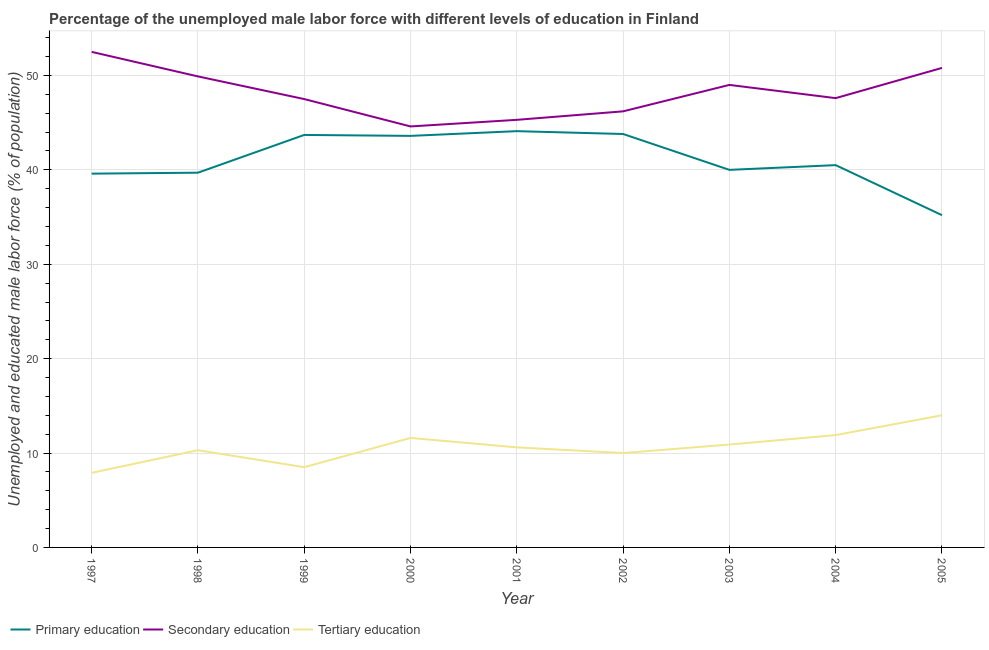How many different coloured lines are there?
Your response must be concise. 3. What is the percentage of male labor force who received primary education in 2005?
Offer a very short reply. 35.2. Across all years, what is the maximum percentage of male labor force who received tertiary education?
Provide a short and direct response. 14. Across all years, what is the minimum percentage of male labor force who received primary education?
Provide a short and direct response. 35.2. In which year was the percentage of male labor force who received primary education maximum?
Provide a succinct answer. 2001. What is the total percentage of male labor force who received secondary education in the graph?
Provide a succinct answer. 433.4. What is the difference between the percentage of male labor force who received secondary education in 2002 and that in 2003?
Ensure brevity in your answer.  -2.8. What is the difference between the percentage of male labor force who received primary education in 2001 and the percentage of male labor force who received tertiary education in 2002?
Provide a short and direct response. 34.1. What is the average percentage of male labor force who received secondary education per year?
Provide a short and direct response. 48.16. In the year 2005, what is the difference between the percentage of male labor force who received primary education and percentage of male labor force who received secondary education?
Offer a terse response. -15.6. What is the ratio of the percentage of male labor force who received secondary education in 1997 to that in 2004?
Make the answer very short. 1.1. What is the difference between the highest and the second highest percentage of male labor force who received secondary education?
Give a very brief answer. 1.7. What is the difference between the highest and the lowest percentage of male labor force who received primary education?
Keep it short and to the point. 8.9. In how many years, is the percentage of male labor force who received primary education greater than the average percentage of male labor force who received primary education taken over all years?
Provide a short and direct response. 4. Is it the case that in every year, the sum of the percentage of male labor force who received primary education and percentage of male labor force who received secondary education is greater than the percentage of male labor force who received tertiary education?
Your answer should be compact. Yes. Is the percentage of male labor force who received tertiary education strictly less than the percentage of male labor force who received secondary education over the years?
Give a very brief answer. Yes. How many lines are there?
Keep it short and to the point. 3. Does the graph contain any zero values?
Your answer should be compact. No. How many legend labels are there?
Your answer should be very brief. 3. What is the title of the graph?
Provide a succinct answer. Percentage of the unemployed male labor force with different levels of education in Finland. What is the label or title of the X-axis?
Your response must be concise. Year. What is the label or title of the Y-axis?
Keep it short and to the point. Unemployed and educated male labor force (% of population). What is the Unemployed and educated male labor force (% of population) in Primary education in 1997?
Your answer should be very brief. 39.6. What is the Unemployed and educated male labor force (% of population) in Secondary education in 1997?
Make the answer very short. 52.5. What is the Unemployed and educated male labor force (% of population) in Tertiary education in 1997?
Make the answer very short. 7.9. What is the Unemployed and educated male labor force (% of population) in Primary education in 1998?
Your answer should be compact. 39.7. What is the Unemployed and educated male labor force (% of population) in Secondary education in 1998?
Provide a short and direct response. 49.9. What is the Unemployed and educated male labor force (% of population) of Tertiary education in 1998?
Your answer should be very brief. 10.3. What is the Unemployed and educated male labor force (% of population) of Primary education in 1999?
Keep it short and to the point. 43.7. What is the Unemployed and educated male labor force (% of population) in Secondary education in 1999?
Offer a terse response. 47.5. What is the Unemployed and educated male labor force (% of population) in Primary education in 2000?
Provide a succinct answer. 43.6. What is the Unemployed and educated male labor force (% of population) in Secondary education in 2000?
Make the answer very short. 44.6. What is the Unemployed and educated male labor force (% of population) of Tertiary education in 2000?
Provide a succinct answer. 11.6. What is the Unemployed and educated male labor force (% of population) of Primary education in 2001?
Make the answer very short. 44.1. What is the Unemployed and educated male labor force (% of population) of Secondary education in 2001?
Provide a succinct answer. 45.3. What is the Unemployed and educated male labor force (% of population) of Tertiary education in 2001?
Keep it short and to the point. 10.6. What is the Unemployed and educated male labor force (% of population) in Primary education in 2002?
Keep it short and to the point. 43.8. What is the Unemployed and educated male labor force (% of population) in Secondary education in 2002?
Make the answer very short. 46.2. What is the Unemployed and educated male labor force (% of population) in Tertiary education in 2002?
Provide a succinct answer. 10. What is the Unemployed and educated male labor force (% of population) of Tertiary education in 2003?
Make the answer very short. 10.9. What is the Unemployed and educated male labor force (% of population) of Primary education in 2004?
Keep it short and to the point. 40.5. What is the Unemployed and educated male labor force (% of population) of Secondary education in 2004?
Make the answer very short. 47.6. What is the Unemployed and educated male labor force (% of population) in Tertiary education in 2004?
Your response must be concise. 11.9. What is the Unemployed and educated male labor force (% of population) of Primary education in 2005?
Ensure brevity in your answer.  35.2. What is the Unemployed and educated male labor force (% of population) of Secondary education in 2005?
Keep it short and to the point. 50.8. Across all years, what is the maximum Unemployed and educated male labor force (% of population) in Primary education?
Your answer should be compact. 44.1. Across all years, what is the maximum Unemployed and educated male labor force (% of population) of Secondary education?
Make the answer very short. 52.5. Across all years, what is the maximum Unemployed and educated male labor force (% of population) of Tertiary education?
Provide a short and direct response. 14. Across all years, what is the minimum Unemployed and educated male labor force (% of population) of Primary education?
Give a very brief answer. 35.2. Across all years, what is the minimum Unemployed and educated male labor force (% of population) of Secondary education?
Offer a terse response. 44.6. Across all years, what is the minimum Unemployed and educated male labor force (% of population) of Tertiary education?
Provide a short and direct response. 7.9. What is the total Unemployed and educated male labor force (% of population) of Primary education in the graph?
Provide a short and direct response. 370.2. What is the total Unemployed and educated male labor force (% of population) in Secondary education in the graph?
Provide a succinct answer. 433.4. What is the total Unemployed and educated male labor force (% of population) in Tertiary education in the graph?
Provide a short and direct response. 95.7. What is the difference between the Unemployed and educated male labor force (% of population) in Tertiary education in 1997 and that in 1998?
Provide a short and direct response. -2.4. What is the difference between the Unemployed and educated male labor force (% of population) in Secondary education in 1997 and that in 1999?
Your response must be concise. 5. What is the difference between the Unemployed and educated male labor force (% of population) in Secondary education in 1997 and that in 2000?
Your response must be concise. 7.9. What is the difference between the Unemployed and educated male labor force (% of population) of Tertiary education in 1997 and that in 2000?
Make the answer very short. -3.7. What is the difference between the Unemployed and educated male labor force (% of population) in Secondary education in 1997 and that in 2001?
Offer a terse response. 7.2. What is the difference between the Unemployed and educated male labor force (% of population) in Primary education in 1997 and that in 2002?
Your response must be concise. -4.2. What is the difference between the Unemployed and educated male labor force (% of population) in Primary education in 1997 and that in 2003?
Make the answer very short. -0.4. What is the difference between the Unemployed and educated male labor force (% of population) in Tertiary education in 1997 and that in 2003?
Keep it short and to the point. -3. What is the difference between the Unemployed and educated male labor force (% of population) of Secondary education in 1997 and that in 2004?
Make the answer very short. 4.9. What is the difference between the Unemployed and educated male labor force (% of population) of Tertiary education in 1997 and that in 2004?
Make the answer very short. -4. What is the difference between the Unemployed and educated male labor force (% of population) in Secondary education in 1997 and that in 2005?
Your response must be concise. 1.7. What is the difference between the Unemployed and educated male labor force (% of population) of Secondary education in 1998 and that in 2000?
Keep it short and to the point. 5.3. What is the difference between the Unemployed and educated male labor force (% of population) in Secondary education in 1998 and that in 2001?
Make the answer very short. 4.6. What is the difference between the Unemployed and educated male labor force (% of population) of Tertiary education in 1998 and that in 2001?
Provide a succinct answer. -0.3. What is the difference between the Unemployed and educated male labor force (% of population) in Secondary education in 1998 and that in 2002?
Keep it short and to the point. 3.7. What is the difference between the Unemployed and educated male labor force (% of population) in Tertiary education in 1998 and that in 2002?
Your answer should be compact. 0.3. What is the difference between the Unemployed and educated male labor force (% of population) in Secondary education in 1998 and that in 2003?
Your response must be concise. 0.9. What is the difference between the Unemployed and educated male labor force (% of population) of Tertiary education in 1998 and that in 2003?
Give a very brief answer. -0.6. What is the difference between the Unemployed and educated male labor force (% of population) of Secondary education in 1998 and that in 2004?
Give a very brief answer. 2.3. What is the difference between the Unemployed and educated male labor force (% of population) in Tertiary education in 1998 and that in 2004?
Keep it short and to the point. -1.6. What is the difference between the Unemployed and educated male labor force (% of population) in Secondary education in 1998 and that in 2005?
Provide a short and direct response. -0.9. What is the difference between the Unemployed and educated male labor force (% of population) in Tertiary education in 1998 and that in 2005?
Provide a short and direct response. -3.7. What is the difference between the Unemployed and educated male labor force (% of population) in Primary education in 1999 and that in 2000?
Your answer should be very brief. 0.1. What is the difference between the Unemployed and educated male labor force (% of population) of Secondary education in 1999 and that in 2000?
Ensure brevity in your answer.  2.9. What is the difference between the Unemployed and educated male labor force (% of population) in Primary education in 1999 and that in 2002?
Make the answer very short. -0.1. What is the difference between the Unemployed and educated male labor force (% of population) of Tertiary education in 1999 and that in 2002?
Provide a succinct answer. -1.5. What is the difference between the Unemployed and educated male labor force (% of population) of Primary education in 1999 and that in 2003?
Offer a terse response. 3.7. What is the difference between the Unemployed and educated male labor force (% of population) of Secondary education in 1999 and that in 2003?
Make the answer very short. -1.5. What is the difference between the Unemployed and educated male labor force (% of population) in Tertiary education in 1999 and that in 2003?
Provide a short and direct response. -2.4. What is the difference between the Unemployed and educated male labor force (% of population) of Tertiary education in 1999 and that in 2004?
Offer a terse response. -3.4. What is the difference between the Unemployed and educated male labor force (% of population) in Primary education in 1999 and that in 2005?
Your answer should be compact. 8.5. What is the difference between the Unemployed and educated male labor force (% of population) in Secondary education in 1999 and that in 2005?
Make the answer very short. -3.3. What is the difference between the Unemployed and educated male labor force (% of population) of Tertiary education in 1999 and that in 2005?
Give a very brief answer. -5.5. What is the difference between the Unemployed and educated male labor force (% of population) in Primary education in 2000 and that in 2001?
Your answer should be compact. -0.5. What is the difference between the Unemployed and educated male labor force (% of population) in Primary education in 2000 and that in 2002?
Provide a short and direct response. -0.2. What is the difference between the Unemployed and educated male labor force (% of population) in Secondary education in 2000 and that in 2002?
Make the answer very short. -1.6. What is the difference between the Unemployed and educated male labor force (% of population) of Primary education in 2000 and that in 2003?
Provide a succinct answer. 3.6. What is the difference between the Unemployed and educated male labor force (% of population) in Tertiary education in 2000 and that in 2003?
Provide a short and direct response. 0.7. What is the difference between the Unemployed and educated male labor force (% of population) in Tertiary education in 2000 and that in 2004?
Provide a short and direct response. -0.3. What is the difference between the Unemployed and educated male labor force (% of population) in Secondary education in 2001 and that in 2002?
Provide a succinct answer. -0.9. What is the difference between the Unemployed and educated male labor force (% of population) of Primary education in 2001 and that in 2003?
Your response must be concise. 4.1. What is the difference between the Unemployed and educated male labor force (% of population) of Secondary education in 2001 and that in 2003?
Provide a succinct answer. -3.7. What is the difference between the Unemployed and educated male labor force (% of population) of Primary education in 2001 and that in 2004?
Give a very brief answer. 3.6. What is the difference between the Unemployed and educated male labor force (% of population) of Secondary education in 2001 and that in 2004?
Offer a very short reply. -2.3. What is the difference between the Unemployed and educated male labor force (% of population) of Tertiary education in 2001 and that in 2004?
Ensure brevity in your answer.  -1.3. What is the difference between the Unemployed and educated male labor force (% of population) in Primary education in 2001 and that in 2005?
Offer a very short reply. 8.9. What is the difference between the Unemployed and educated male labor force (% of population) of Secondary education in 2002 and that in 2003?
Provide a short and direct response. -2.8. What is the difference between the Unemployed and educated male labor force (% of population) of Tertiary education in 2002 and that in 2004?
Offer a very short reply. -1.9. What is the difference between the Unemployed and educated male labor force (% of population) of Tertiary education in 2002 and that in 2005?
Your answer should be very brief. -4. What is the difference between the Unemployed and educated male labor force (% of population) in Primary education in 2003 and that in 2004?
Provide a short and direct response. -0.5. What is the difference between the Unemployed and educated male labor force (% of population) of Secondary education in 2003 and that in 2004?
Provide a succinct answer. 1.4. What is the difference between the Unemployed and educated male labor force (% of population) of Primary education in 2003 and that in 2005?
Give a very brief answer. 4.8. What is the difference between the Unemployed and educated male labor force (% of population) of Tertiary education in 2003 and that in 2005?
Your answer should be very brief. -3.1. What is the difference between the Unemployed and educated male labor force (% of population) of Tertiary education in 2004 and that in 2005?
Your answer should be compact. -2.1. What is the difference between the Unemployed and educated male labor force (% of population) of Primary education in 1997 and the Unemployed and educated male labor force (% of population) of Tertiary education in 1998?
Keep it short and to the point. 29.3. What is the difference between the Unemployed and educated male labor force (% of population) of Secondary education in 1997 and the Unemployed and educated male labor force (% of population) of Tertiary education in 1998?
Keep it short and to the point. 42.2. What is the difference between the Unemployed and educated male labor force (% of population) of Primary education in 1997 and the Unemployed and educated male labor force (% of population) of Tertiary education in 1999?
Provide a succinct answer. 31.1. What is the difference between the Unemployed and educated male labor force (% of population) in Secondary education in 1997 and the Unemployed and educated male labor force (% of population) in Tertiary education in 2000?
Ensure brevity in your answer.  40.9. What is the difference between the Unemployed and educated male labor force (% of population) in Primary education in 1997 and the Unemployed and educated male labor force (% of population) in Secondary education in 2001?
Provide a short and direct response. -5.7. What is the difference between the Unemployed and educated male labor force (% of population) in Primary education in 1997 and the Unemployed and educated male labor force (% of population) in Tertiary education in 2001?
Give a very brief answer. 29. What is the difference between the Unemployed and educated male labor force (% of population) in Secondary education in 1997 and the Unemployed and educated male labor force (% of population) in Tertiary education in 2001?
Your answer should be compact. 41.9. What is the difference between the Unemployed and educated male labor force (% of population) of Primary education in 1997 and the Unemployed and educated male labor force (% of population) of Tertiary education in 2002?
Provide a short and direct response. 29.6. What is the difference between the Unemployed and educated male labor force (% of population) of Secondary education in 1997 and the Unemployed and educated male labor force (% of population) of Tertiary education in 2002?
Your response must be concise. 42.5. What is the difference between the Unemployed and educated male labor force (% of population) of Primary education in 1997 and the Unemployed and educated male labor force (% of population) of Tertiary education in 2003?
Give a very brief answer. 28.7. What is the difference between the Unemployed and educated male labor force (% of population) of Secondary education in 1997 and the Unemployed and educated male labor force (% of population) of Tertiary education in 2003?
Provide a succinct answer. 41.6. What is the difference between the Unemployed and educated male labor force (% of population) of Primary education in 1997 and the Unemployed and educated male labor force (% of population) of Secondary education in 2004?
Offer a terse response. -8. What is the difference between the Unemployed and educated male labor force (% of population) in Primary education in 1997 and the Unemployed and educated male labor force (% of population) in Tertiary education in 2004?
Your answer should be very brief. 27.7. What is the difference between the Unemployed and educated male labor force (% of population) of Secondary education in 1997 and the Unemployed and educated male labor force (% of population) of Tertiary education in 2004?
Ensure brevity in your answer.  40.6. What is the difference between the Unemployed and educated male labor force (% of population) of Primary education in 1997 and the Unemployed and educated male labor force (% of population) of Tertiary education in 2005?
Keep it short and to the point. 25.6. What is the difference between the Unemployed and educated male labor force (% of population) of Secondary education in 1997 and the Unemployed and educated male labor force (% of population) of Tertiary education in 2005?
Provide a short and direct response. 38.5. What is the difference between the Unemployed and educated male labor force (% of population) in Primary education in 1998 and the Unemployed and educated male labor force (% of population) in Secondary education in 1999?
Provide a short and direct response. -7.8. What is the difference between the Unemployed and educated male labor force (% of population) in Primary education in 1998 and the Unemployed and educated male labor force (% of population) in Tertiary education in 1999?
Keep it short and to the point. 31.2. What is the difference between the Unemployed and educated male labor force (% of population) of Secondary education in 1998 and the Unemployed and educated male labor force (% of population) of Tertiary education in 1999?
Keep it short and to the point. 41.4. What is the difference between the Unemployed and educated male labor force (% of population) in Primary education in 1998 and the Unemployed and educated male labor force (% of population) in Secondary education in 2000?
Your response must be concise. -4.9. What is the difference between the Unemployed and educated male labor force (% of population) of Primary education in 1998 and the Unemployed and educated male labor force (% of population) of Tertiary education in 2000?
Your response must be concise. 28.1. What is the difference between the Unemployed and educated male labor force (% of population) of Secondary education in 1998 and the Unemployed and educated male labor force (% of population) of Tertiary education in 2000?
Offer a terse response. 38.3. What is the difference between the Unemployed and educated male labor force (% of population) of Primary education in 1998 and the Unemployed and educated male labor force (% of population) of Secondary education in 2001?
Your answer should be very brief. -5.6. What is the difference between the Unemployed and educated male labor force (% of population) of Primary education in 1998 and the Unemployed and educated male labor force (% of population) of Tertiary education in 2001?
Your answer should be very brief. 29.1. What is the difference between the Unemployed and educated male labor force (% of population) of Secondary education in 1998 and the Unemployed and educated male labor force (% of population) of Tertiary education in 2001?
Your answer should be compact. 39.3. What is the difference between the Unemployed and educated male labor force (% of population) in Primary education in 1998 and the Unemployed and educated male labor force (% of population) in Tertiary education in 2002?
Your answer should be very brief. 29.7. What is the difference between the Unemployed and educated male labor force (% of population) of Secondary education in 1998 and the Unemployed and educated male labor force (% of population) of Tertiary education in 2002?
Provide a short and direct response. 39.9. What is the difference between the Unemployed and educated male labor force (% of population) of Primary education in 1998 and the Unemployed and educated male labor force (% of population) of Secondary education in 2003?
Provide a succinct answer. -9.3. What is the difference between the Unemployed and educated male labor force (% of population) in Primary education in 1998 and the Unemployed and educated male labor force (% of population) in Tertiary education in 2003?
Your response must be concise. 28.8. What is the difference between the Unemployed and educated male labor force (% of population) in Primary education in 1998 and the Unemployed and educated male labor force (% of population) in Tertiary education in 2004?
Your response must be concise. 27.8. What is the difference between the Unemployed and educated male labor force (% of population) of Secondary education in 1998 and the Unemployed and educated male labor force (% of population) of Tertiary education in 2004?
Keep it short and to the point. 38. What is the difference between the Unemployed and educated male labor force (% of population) in Primary education in 1998 and the Unemployed and educated male labor force (% of population) in Secondary education in 2005?
Provide a short and direct response. -11.1. What is the difference between the Unemployed and educated male labor force (% of population) of Primary education in 1998 and the Unemployed and educated male labor force (% of population) of Tertiary education in 2005?
Your answer should be very brief. 25.7. What is the difference between the Unemployed and educated male labor force (% of population) in Secondary education in 1998 and the Unemployed and educated male labor force (% of population) in Tertiary education in 2005?
Ensure brevity in your answer.  35.9. What is the difference between the Unemployed and educated male labor force (% of population) of Primary education in 1999 and the Unemployed and educated male labor force (% of population) of Secondary education in 2000?
Offer a terse response. -0.9. What is the difference between the Unemployed and educated male labor force (% of population) in Primary education in 1999 and the Unemployed and educated male labor force (% of population) in Tertiary education in 2000?
Your response must be concise. 32.1. What is the difference between the Unemployed and educated male labor force (% of population) in Secondary education in 1999 and the Unemployed and educated male labor force (% of population) in Tertiary education in 2000?
Provide a short and direct response. 35.9. What is the difference between the Unemployed and educated male labor force (% of population) of Primary education in 1999 and the Unemployed and educated male labor force (% of population) of Tertiary education in 2001?
Offer a very short reply. 33.1. What is the difference between the Unemployed and educated male labor force (% of population) in Secondary education in 1999 and the Unemployed and educated male labor force (% of population) in Tertiary education in 2001?
Your answer should be very brief. 36.9. What is the difference between the Unemployed and educated male labor force (% of population) in Primary education in 1999 and the Unemployed and educated male labor force (% of population) in Tertiary education in 2002?
Your response must be concise. 33.7. What is the difference between the Unemployed and educated male labor force (% of population) in Secondary education in 1999 and the Unemployed and educated male labor force (% of population) in Tertiary education in 2002?
Provide a short and direct response. 37.5. What is the difference between the Unemployed and educated male labor force (% of population) in Primary education in 1999 and the Unemployed and educated male labor force (% of population) in Secondary education in 2003?
Ensure brevity in your answer.  -5.3. What is the difference between the Unemployed and educated male labor force (% of population) of Primary education in 1999 and the Unemployed and educated male labor force (% of population) of Tertiary education in 2003?
Offer a terse response. 32.8. What is the difference between the Unemployed and educated male labor force (% of population) in Secondary education in 1999 and the Unemployed and educated male labor force (% of population) in Tertiary education in 2003?
Make the answer very short. 36.6. What is the difference between the Unemployed and educated male labor force (% of population) in Primary education in 1999 and the Unemployed and educated male labor force (% of population) in Secondary education in 2004?
Your answer should be compact. -3.9. What is the difference between the Unemployed and educated male labor force (% of population) of Primary education in 1999 and the Unemployed and educated male labor force (% of population) of Tertiary education in 2004?
Offer a very short reply. 31.8. What is the difference between the Unemployed and educated male labor force (% of population) in Secondary education in 1999 and the Unemployed and educated male labor force (% of population) in Tertiary education in 2004?
Make the answer very short. 35.6. What is the difference between the Unemployed and educated male labor force (% of population) of Primary education in 1999 and the Unemployed and educated male labor force (% of population) of Secondary education in 2005?
Offer a terse response. -7.1. What is the difference between the Unemployed and educated male labor force (% of population) of Primary education in 1999 and the Unemployed and educated male labor force (% of population) of Tertiary education in 2005?
Make the answer very short. 29.7. What is the difference between the Unemployed and educated male labor force (% of population) in Secondary education in 1999 and the Unemployed and educated male labor force (% of population) in Tertiary education in 2005?
Give a very brief answer. 33.5. What is the difference between the Unemployed and educated male labor force (% of population) of Secondary education in 2000 and the Unemployed and educated male labor force (% of population) of Tertiary education in 2001?
Provide a short and direct response. 34. What is the difference between the Unemployed and educated male labor force (% of population) of Primary education in 2000 and the Unemployed and educated male labor force (% of population) of Tertiary education in 2002?
Give a very brief answer. 33.6. What is the difference between the Unemployed and educated male labor force (% of population) in Secondary education in 2000 and the Unemployed and educated male labor force (% of population) in Tertiary education in 2002?
Ensure brevity in your answer.  34.6. What is the difference between the Unemployed and educated male labor force (% of population) in Primary education in 2000 and the Unemployed and educated male labor force (% of population) in Tertiary education in 2003?
Make the answer very short. 32.7. What is the difference between the Unemployed and educated male labor force (% of population) in Secondary education in 2000 and the Unemployed and educated male labor force (% of population) in Tertiary education in 2003?
Make the answer very short. 33.7. What is the difference between the Unemployed and educated male labor force (% of population) in Primary education in 2000 and the Unemployed and educated male labor force (% of population) in Secondary education in 2004?
Your answer should be compact. -4. What is the difference between the Unemployed and educated male labor force (% of population) of Primary education in 2000 and the Unemployed and educated male labor force (% of population) of Tertiary education in 2004?
Ensure brevity in your answer.  31.7. What is the difference between the Unemployed and educated male labor force (% of population) in Secondary education in 2000 and the Unemployed and educated male labor force (% of population) in Tertiary education in 2004?
Offer a terse response. 32.7. What is the difference between the Unemployed and educated male labor force (% of population) of Primary education in 2000 and the Unemployed and educated male labor force (% of population) of Tertiary education in 2005?
Offer a terse response. 29.6. What is the difference between the Unemployed and educated male labor force (% of population) in Secondary education in 2000 and the Unemployed and educated male labor force (% of population) in Tertiary education in 2005?
Give a very brief answer. 30.6. What is the difference between the Unemployed and educated male labor force (% of population) of Primary education in 2001 and the Unemployed and educated male labor force (% of population) of Tertiary education in 2002?
Ensure brevity in your answer.  34.1. What is the difference between the Unemployed and educated male labor force (% of population) in Secondary education in 2001 and the Unemployed and educated male labor force (% of population) in Tertiary education in 2002?
Keep it short and to the point. 35.3. What is the difference between the Unemployed and educated male labor force (% of population) in Primary education in 2001 and the Unemployed and educated male labor force (% of population) in Secondary education in 2003?
Offer a terse response. -4.9. What is the difference between the Unemployed and educated male labor force (% of population) in Primary education in 2001 and the Unemployed and educated male labor force (% of population) in Tertiary education in 2003?
Ensure brevity in your answer.  33.2. What is the difference between the Unemployed and educated male labor force (% of population) in Secondary education in 2001 and the Unemployed and educated male labor force (% of population) in Tertiary education in 2003?
Give a very brief answer. 34.4. What is the difference between the Unemployed and educated male labor force (% of population) of Primary education in 2001 and the Unemployed and educated male labor force (% of population) of Tertiary education in 2004?
Provide a short and direct response. 32.2. What is the difference between the Unemployed and educated male labor force (% of population) in Secondary education in 2001 and the Unemployed and educated male labor force (% of population) in Tertiary education in 2004?
Make the answer very short. 33.4. What is the difference between the Unemployed and educated male labor force (% of population) in Primary education in 2001 and the Unemployed and educated male labor force (% of population) in Tertiary education in 2005?
Provide a succinct answer. 30.1. What is the difference between the Unemployed and educated male labor force (% of population) of Secondary education in 2001 and the Unemployed and educated male labor force (% of population) of Tertiary education in 2005?
Your answer should be compact. 31.3. What is the difference between the Unemployed and educated male labor force (% of population) in Primary education in 2002 and the Unemployed and educated male labor force (% of population) in Secondary education in 2003?
Offer a terse response. -5.2. What is the difference between the Unemployed and educated male labor force (% of population) of Primary education in 2002 and the Unemployed and educated male labor force (% of population) of Tertiary education in 2003?
Keep it short and to the point. 32.9. What is the difference between the Unemployed and educated male labor force (% of population) of Secondary education in 2002 and the Unemployed and educated male labor force (% of population) of Tertiary education in 2003?
Make the answer very short. 35.3. What is the difference between the Unemployed and educated male labor force (% of population) in Primary education in 2002 and the Unemployed and educated male labor force (% of population) in Tertiary education in 2004?
Your answer should be compact. 31.9. What is the difference between the Unemployed and educated male labor force (% of population) in Secondary education in 2002 and the Unemployed and educated male labor force (% of population) in Tertiary education in 2004?
Make the answer very short. 34.3. What is the difference between the Unemployed and educated male labor force (% of population) of Primary education in 2002 and the Unemployed and educated male labor force (% of population) of Tertiary education in 2005?
Your answer should be compact. 29.8. What is the difference between the Unemployed and educated male labor force (% of population) in Secondary education in 2002 and the Unemployed and educated male labor force (% of population) in Tertiary education in 2005?
Ensure brevity in your answer.  32.2. What is the difference between the Unemployed and educated male labor force (% of population) in Primary education in 2003 and the Unemployed and educated male labor force (% of population) in Tertiary education in 2004?
Give a very brief answer. 28.1. What is the difference between the Unemployed and educated male labor force (% of population) in Secondary education in 2003 and the Unemployed and educated male labor force (% of population) in Tertiary education in 2004?
Ensure brevity in your answer.  37.1. What is the difference between the Unemployed and educated male labor force (% of population) in Primary education in 2003 and the Unemployed and educated male labor force (% of population) in Tertiary education in 2005?
Your answer should be very brief. 26. What is the difference between the Unemployed and educated male labor force (% of population) in Secondary education in 2004 and the Unemployed and educated male labor force (% of population) in Tertiary education in 2005?
Offer a very short reply. 33.6. What is the average Unemployed and educated male labor force (% of population) in Primary education per year?
Provide a succinct answer. 41.13. What is the average Unemployed and educated male labor force (% of population) in Secondary education per year?
Offer a very short reply. 48.16. What is the average Unemployed and educated male labor force (% of population) of Tertiary education per year?
Your answer should be very brief. 10.63. In the year 1997, what is the difference between the Unemployed and educated male labor force (% of population) in Primary education and Unemployed and educated male labor force (% of population) in Secondary education?
Provide a short and direct response. -12.9. In the year 1997, what is the difference between the Unemployed and educated male labor force (% of population) in Primary education and Unemployed and educated male labor force (% of population) in Tertiary education?
Keep it short and to the point. 31.7. In the year 1997, what is the difference between the Unemployed and educated male labor force (% of population) in Secondary education and Unemployed and educated male labor force (% of population) in Tertiary education?
Your answer should be compact. 44.6. In the year 1998, what is the difference between the Unemployed and educated male labor force (% of population) of Primary education and Unemployed and educated male labor force (% of population) of Tertiary education?
Offer a terse response. 29.4. In the year 1998, what is the difference between the Unemployed and educated male labor force (% of population) of Secondary education and Unemployed and educated male labor force (% of population) of Tertiary education?
Your answer should be very brief. 39.6. In the year 1999, what is the difference between the Unemployed and educated male labor force (% of population) in Primary education and Unemployed and educated male labor force (% of population) in Tertiary education?
Make the answer very short. 35.2. In the year 2000, what is the difference between the Unemployed and educated male labor force (% of population) of Primary education and Unemployed and educated male labor force (% of population) of Secondary education?
Your response must be concise. -1. In the year 2001, what is the difference between the Unemployed and educated male labor force (% of population) of Primary education and Unemployed and educated male labor force (% of population) of Tertiary education?
Make the answer very short. 33.5. In the year 2001, what is the difference between the Unemployed and educated male labor force (% of population) of Secondary education and Unemployed and educated male labor force (% of population) of Tertiary education?
Make the answer very short. 34.7. In the year 2002, what is the difference between the Unemployed and educated male labor force (% of population) of Primary education and Unemployed and educated male labor force (% of population) of Tertiary education?
Provide a succinct answer. 33.8. In the year 2002, what is the difference between the Unemployed and educated male labor force (% of population) in Secondary education and Unemployed and educated male labor force (% of population) in Tertiary education?
Provide a succinct answer. 36.2. In the year 2003, what is the difference between the Unemployed and educated male labor force (% of population) of Primary education and Unemployed and educated male labor force (% of population) of Tertiary education?
Offer a terse response. 29.1. In the year 2003, what is the difference between the Unemployed and educated male labor force (% of population) in Secondary education and Unemployed and educated male labor force (% of population) in Tertiary education?
Your answer should be compact. 38.1. In the year 2004, what is the difference between the Unemployed and educated male labor force (% of population) in Primary education and Unemployed and educated male labor force (% of population) in Secondary education?
Make the answer very short. -7.1. In the year 2004, what is the difference between the Unemployed and educated male labor force (% of population) in Primary education and Unemployed and educated male labor force (% of population) in Tertiary education?
Your response must be concise. 28.6. In the year 2004, what is the difference between the Unemployed and educated male labor force (% of population) of Secondary education and Unemployed and educated male labor force (% of population) of Tertiary education?
Provide a succinct answer. 35.7. In the year 2005, what is the difference between the Unemployed and educated male labor force (% of population) in Primary education and Unemployed and educated male labor force (% of population) in Secondary education?
Ensure brevity in your answer.  -15.6. In the year 2005, what is the difference between the Unemployed and educated male labor force (% of population) of Primary education and Unemployed and educated male labor force (% of population) of Tertiary education?
Ensure brevity in your answer.  21.2. In the year 2005, what is the difference between the Unemployed and educated male labor force (% of population) of Secondary education and Unemployed and educated male labor force (% of population) of Tertiary education?
Give a very brief answer. 36.8. What is the ratio of the Unemployed and educated male labor force (% of population) in Primary education in 1997 to that in 1998?
Your response must be concise. 1. What is the ratio of the Unemployed and educated male labor force (% of population) in Secondary education in 1997 to that in 1998?
Your answer should be very brief. 1.05. What is the ratio of the Unemployed and educated male labor force (% of population) of Tertiary education in 1997 to that in 1998?
Offer a very short reply. 0.77. What is the ratio of the Unemployed and educated male labor force (% of population) of Primary education in 1997 to that in 1999?
Provide a succinct answer. 0.91. What is the ratio of the Unemployed and educated male labor force (% of population) of Secondary education in 1997 to that in 1999?
Give a very brief answer. 1.11. What is the ratio of the Unemployed and educated male labor force (% of population) in Tertiary education in 1997 to that in 1999?
Your answer should be very brief. 0.93. What is the ratio of the Unemployed and educated male labor force (% of population) in Primary education in 1997 to that in 2000?
Make the answer very short. 0.91. What is the ratio of the Unemployed and educated male labor force (% of population) in Secondary education in 1997 to that in 2000?
Ensure brevity in your answer.  1.18. What is the ratio of the Unemployed and educated male labor force (% of population) of Tertiary education in 1997 to that in 2000?
Make the answer very short. 0.68. What is the ratio of the Unemployed and educated male labor force (% of population) in Primary education in 1997 to that in 2001?
Ensure brevity in your answer.  0.9. What is the ratio of the Unemployed and educated male labor force (% of population) of Secondary education in 1997 to that in 2001?
Keep it short and to the point. 1.16. What is the ratio of the Unemployed and educated male labor force (% of population) in Tertiary education in 1997 to that in 2001?
Your response must be concise. 0.75. What is the ratio of the Unemployed and educated male labor force (% of population) in Primary education in 1997 to that in 2002?
Give a very brief answer. 0.9. What is the ratio of the Unemployed and educated male labor force (% of population) in Secondary education in 1997 to that in 2002?
Your answer should be very brief. 1.14. What is the ratio of the Unemployed and educated male labor force (% of population) of Tertiary education in 1997 to that in 2002?
Your response must be concise. 0.79. What is the ratio of the Unemployed and educated male labor force (% of population) of Secondary education in 1997 to that in 2003?
Your answer should be compact. 1.07. What is the ratio of the Unemployed and educated male labor force (% of population) of Tertiary education in 1997 to that in 2003?
Ensure brevity in your answer.  0.72. What is the ratio of the Unemployed and educated male labor force (% of population) of Primary education in 1997 to that in 2004?
Your response must be concise. 0.98. What is the ratio of the Unemployed and educated male labor force (% of population) in Secondary education in 1997 to that in 2004?
Your answer should be very brief. 1.1. What is the ratio of the Unemployed and educated male labor force (% of population) in Tertiary education in 1997 to that in 2004?
Provide a succinct answer. 0.66. What is the ratio of the Unemployed and educated male labor force (% of population) in Secondary education in 1997 to that in 2005?
Provide a short and direct response. 1.03. What is the ratio of the Unemployed and educated male labor force (% of population) in Tertiary education in 1997 to that in 2005?
Offer a very short reply. 0.56. What is the ratio of the Unemployed and educated male labor force (% of population) of Primary education in 1998 to that in 1999?
Give a very brief answer. 0.91. What is the ratio of the Unemployed and educated male labor force (% of population) of Secondary education in 1998 to that in 1999?
Your answer should be compact. 1.05. What is the ratio of the Unemployed and educated male labor force (% of population) of Tertiary education in 1998 to that in 1999?
Your answer should be compact. 1.21. What is the ratio of the Unemployed and educated male labor force (% of population) of Primary education in 1998 to that in 2000?
Your answer should be very brief. 0.91. What is the ratio of the Unemployed and educated male labor force (% of population) of Secondary education in 1998 to that in 2000?
Ensure brevity in your answer.  1.12. What is the ratio of the Unemployed and educated male labor force (% of population) of Tertiary education in 1998 to that in 2000?
Offer a very short reply. 0.89. What is the ratio of the Unemployed and educated male labor force (% of population) of Primary education in 1998 to that in 2001?
Provide a succinct answer. 0.9. What is the ratio of the Unemployed and educated male labor force (% of population) in Secondary education in 1998 to that in 2001?
Ensure brevity in your answer.  1.1. What is the ratio of the Unemployed and educated male labor force (% of population) in Tertiary education in 1998 to that in 2001?
Keep it short and to the point. 0.97. What is the ratio of the Unemployed and educated male labor force (% of population) in Primary education in 1998 to that in 2002?
Make the answer very short. 0.91. What is the ratio of the Unemployed and educated male labor force (% of population) in Secondary education in 1998 to that in 2002?
Provide a short and direct response. 1.08. What is the ratio of the Unemployed and educated male labor force (% of population) of Secondary education in 1998 to that in 2003?
Make the answer very short. 1.02. What is the ratio of the Unemployed and educated male labor force (% of population) of Tertiary education in 1998 to that in 2003?
Give a very brief answer. 0.94. What is the ratio of the Unemployed and educated male labor force (% of population) in Primary education in 1998 to that in 2004?
Your response must be concise. 0.98. What is the ratio of the Unemployed and educated male labor force (% of population) of Secondary education in 1998 to that in 2004?
Your answer should be very brief. 1.05. What is the ratio of the Unemployed and educated male labor force (% of population) of Tertiary education in 1998 to that in 2004?
Ensure brevity in your answer.  0.87. What is the ratio of the Unemployed and educated male labor force (% of population) in Primary education in 1998 to that in 2005?
Your answer should be compact. 1.13. What is the ratio of the Unemployed and educated male labor force (% of population) of Secondary education in 1998 to that in 2005?
Provide a succinct answer. 0.98. What is the ratio of the Unemployed and educated male labor force (% of population) in Tertiary education in 1998 to that in 2005?
Offer a very short reply. 0.74. What is the ratio of the Unemployed and educated male labor force (% of population) of Secondary education in 1999 to that in 2000?
Give a very brief answer. 1.06. What is the ratio of the Unemployed and educated male labor force (% of population) in Tertiary education in 1999 to that in 2000?
Provide a short and direct response. 0.73. What is the ratio of the Unemployed and educated male labor force (% of population) in Primary education in 1999 to that in 2001?
Your response must be concise. 0.99. What is the ratio of the Unemployed and educated male labor force (% of population) in Secondary education in 1999 to that in 2001?
Your answer should be compact. 1.05. What is the ratio of the Unemployed and educated male labor force (% of population) in Tertiary education in 1999 to that in 2001?
Your response must be concise. 0.8. What is the ratio of the Unemployed and educated male labor force (% of population) of Primary education in 1999 to that in 2002?
Give a very brief answer. 1. What is the ratio of the Unemployed and educated male labor force (% of population) of Secondary education in 1999 to that in 2002?
Your answer should be compact. 1.03. What is the ratio of the Unemployed and educated male labor force (% of population) of Primary education in 1999 to that in 2003?
Your answer should be very brief. 1.09. What is the ratio of the Unemployed and educated male labor force (% of population) in Secondary education in 1999 to that in 2003?
Provide a succinct answer. 0.97. What is the ratio of the Unemployed and educated male labor force (% of population) in Tertiary education in 1999 to that in 2003?
Give a very brief answer. 0.78. What is the ratio of the Unemployed and educated male labor force (% of population) in Primary education in 1999 to that in 2004?
Ensure brevity in your answer.  1.08. What is the ratio of the Unemployed and educated male labor force (% of population) in Secondary education in 1999 to that in 2004?
Offer a terse response. 1. What is the ratio of the Unemployed and educated male labor force (% of population) in Tertiary education in 1999 to that in 2004?
Your answer should be compact. 0.71. What is the ratio of the Unemployed and educated male labor force (% of population) in Primary education in 1999 to that in 2005?
Ensure brevity in your answer.  1.24. What is the ratio of the Unemployed and educated male labor force (% of population) of Secondary education in 1999 to that in 2005?
Your response must be concise. 0.94. What is the ratio of the Unemployed and educated male labor force (% of population) of Tertiary education in 1999 to that in 2005?
Ensure brevity in your answer.  0.61. What is the ratio of the Unemployed and educated male labor force (% of population) of Primary education in 2000 to that in 2001?
Your answer should be compact. 0.99. What is the ratio of the Unemployed and educated male labor force (% of population) of Secondary education in 2000 to that in 2001?
Offer a very short reply. 0.98. What is the ratio of the Unemployed and educated male labor force (% of population) of Tertiary education in 2000 to that in 2001?
Offer a terse response. 1.09. What is the ratio of the Unemployed and educated male labor force (% of population) of Secondary education in 2000 to that in 2002?
Ensure brevity in your answer.  0.97. What is the ratio of the Unemployed and educated male labor force (% of population) of Tertiary education in 2000 to that in 2002?
Offer a very short reply. 1.16. What is the ratio of the Unemployed and educated male labor force (% of population) in Primary education in 2000 to that in 2003?
Make the answer very short. 1.09. What is the ratio of the Unemployed and educated male labor force (% of population) of Secondary education in 2000 to that in 2003?
Make the answer very short. 0.91. What is the ratio of the Unemployed and educated male labor force (% of population) of Tertiary education in 2000 to that in 2003?
Provide a succinct answer. 1.06. What is the ratio of the Unemployed and educated male labor force (% of population) in Primary education in 2000 to that in 2004?
Your answer should be compact. 1.08. What is the ratio of the Unemployed and educated male labor force (% of population) of Secondary education in 2000 to that in 2004?
Your answer should be compact. 0.94. What is the ratio of the Unemployed and educated male labor force (% of population) of Tertiary education in 2000 to that in 2004?
Make the answer very short. 0.97. What is the ratio of the Unemployed and educated male labor force (% of population) in Primary education in 2000 to that in 2005?
Your answer should be very brief. 1.24. What is the ratio of the Unemployed and educated male labor force (% of population) of Secondary education in 2000 to that in 2005?
Offer a terse response. 0.88. What is the ratio of the Unemployed and educated male labor force (% of population) of Tertiary education in 2000 to that in 2005?
Provide a succinct answer. 0.83. What is the ratio of the Unemployed and educated male labor force (% of population) of Primary education in 2001 to that in 2002?
Provide a succinct answer. 1.01. What is the ratio of the Unemployed and educated male labor force (% of population) in Secondary education in 2001 to that in 2002?
Provide a succinct answer. 0.98. What is the ratio of the Unemployed and educated male labor force (% of population) of Tertiary education in 2001 to that in 2002?
Ensure brevity in your answer.  1.06. What is the ratio of the Unemployed and educated male labor force (% of population) of Primary education in 2001 to that in 2003?
Ensure brevity in your answer.  1.1. What is the ratio of the Unemployed and educated male labor force (% of population) of Secondary education in 2001 to that in 2003?
Your answer should be very brief. 0.92. What is the ratio of the Unemployed and educated male labor force (% of population) in Tertiary education in 2001 to that in 2003?
Ensure brevity in your answer.  0.97. What is the ratio of the Unemployed and educated male labor force (% of population) of Primary education in 2001 to that in 2004?
Ensure brevity in your answer.  1.09. What is the ratio of the Unemployed and educated male labor force (% of population) of Secondary education in 2001 to that in 2004?
Keep it short and to the point. 0.95. What is the ratio of the Unemployed and educated male labor force (% of population) in Tertiary education in 2001 to that in 2004?
Provide a short and direct response. 0.89. What is the ratio of the Unemployed and educated male labor force (% of population) of Primary education in 2001 to that in 2005?
Offer a terse response. 1.25. What is the ratio of the Unemployed and educated male labor force (% of population) of Secondary education in 2001 to that in 2005?
Provide a succinct answer. 0.89. What is the ratio of the Unemployed and educated male labor force (% of population) of Tertiary education in 2001 to that in 2005?
Your answer should be very brief. 0.76. What is the ratio of the Unemployed and educated male labor force (% of population) in Primary education in 2002 to that in 2003?
Offer a very short reply. 1.09. What is the ratio of the Unemployed and educated male labor force (% of population) in Secondary education in 2002 to that in 2003?
Keep it short and to the point. 0.94. What is the ratio of the Unemployed and educated male labor force (% of population) of Tertiary education in 2002 to that in 2003?
Make the answer very short. 0.92. What is the ratio of the Unemployed and educated male labor force (% of population) of Primary education in 2002 to that in 2004?
Your answer should be compact. 1.08. What is the ratio of the Unemployed and educated male labor force (% of population) of Secondary education in 2002 to that in 2004?
Your answer should be very brief. 0.97. What is the ratio of the Unemployed and educated male labor force (% of population) in Tertiary education in 2002 to that in 2004?
Provide a short and direct response. 0.84. What is the ratio of the Unemployed and educated male labor force (% of population) in Primary education in 2002 to that in 2005?
Your answer should be very brief. 1.24. What is the ratio of the Unemployed and educated male labor force (% of population) in Secondary education in 2002 to that in 2005?
Provide a short and direct response. 0.91. What is the ratio of the Unemployed and educated male labor force (% of population) of Tertiary education in 2002 to that in 2005?
Offer a very short reply. 0.71. What is the ratio of the Unemployed and educated male labor force (% of population) of Secondary education in 2003 to that in 2004?
Offer a very short reply. 1.03. What is the ratio of the Unemployed and educated male labor force (% of population) of Tertiary education in 2003 to that in 2004?
Your answer should be very brief. 0.92. What is the ratio of the Unemployed and educated male labor force (% of population) of Primary education in 2003 to that in 2005?
Offer a very short reply. 1.14. What is the ratio of the Unemployed and educated male labor force (% of population) of Secondary education in 2003 to that in 2005?
Your response must be concise. 0.96. What is the ratio of the Unemployed and educated male labor force (% of population) of Tertiary education in 2003 to that in 2005?
Your answer should be compact. 0.78. What is the ratio of the Unemployed and educated male labor force (% of population) in Primary education in 2004 to that in 2005?
Offer a terse response. 1.15. What is the ratio of the Unemployed and educated male labor force (% of population) of Secondary education in 2004 to that in 2005?
Ensure brevity in your answer.  0.94. What is the ratio of the Unemployed and educated male labor force (% of population) of Tertiary education in 2004 to that in 2005?
Keep it short and to the point. 0.85. What is the difference between the highest and the second highest Unemployed and educated male labor force (% of population) in Primary education?
Provide a succinct answer. 0.3. What is the difference between the highest and the second highest Unemployed and educated male labor force (% of population) of Secondary education?
Offer a terse response. 1.7. What is the difference between the highest and the second highest Unemployed and educated male labor force (% of population) in Tertiary education?
Ensure brevity in your answer.  2.1. 